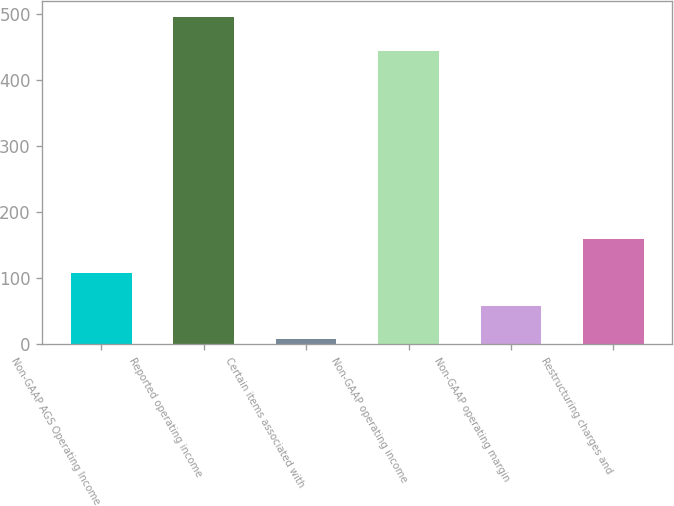Convert chart. <chart><loc_0><loc_0><loc_500><loc_500><bar_chart><fcel>Non-GAAP AGS Operating Income<fcel>Reported operating income<fcel>Certain items associated with<fcel>Non-GAAP operating income<fcel>Non-GAAP operating margin<fcel>Restructuring charges and<nl><fcel>108.2<fcel>494.6<fcel>7<fcel>444<fcel>57.6<fcel>158.8<nl></chart> 